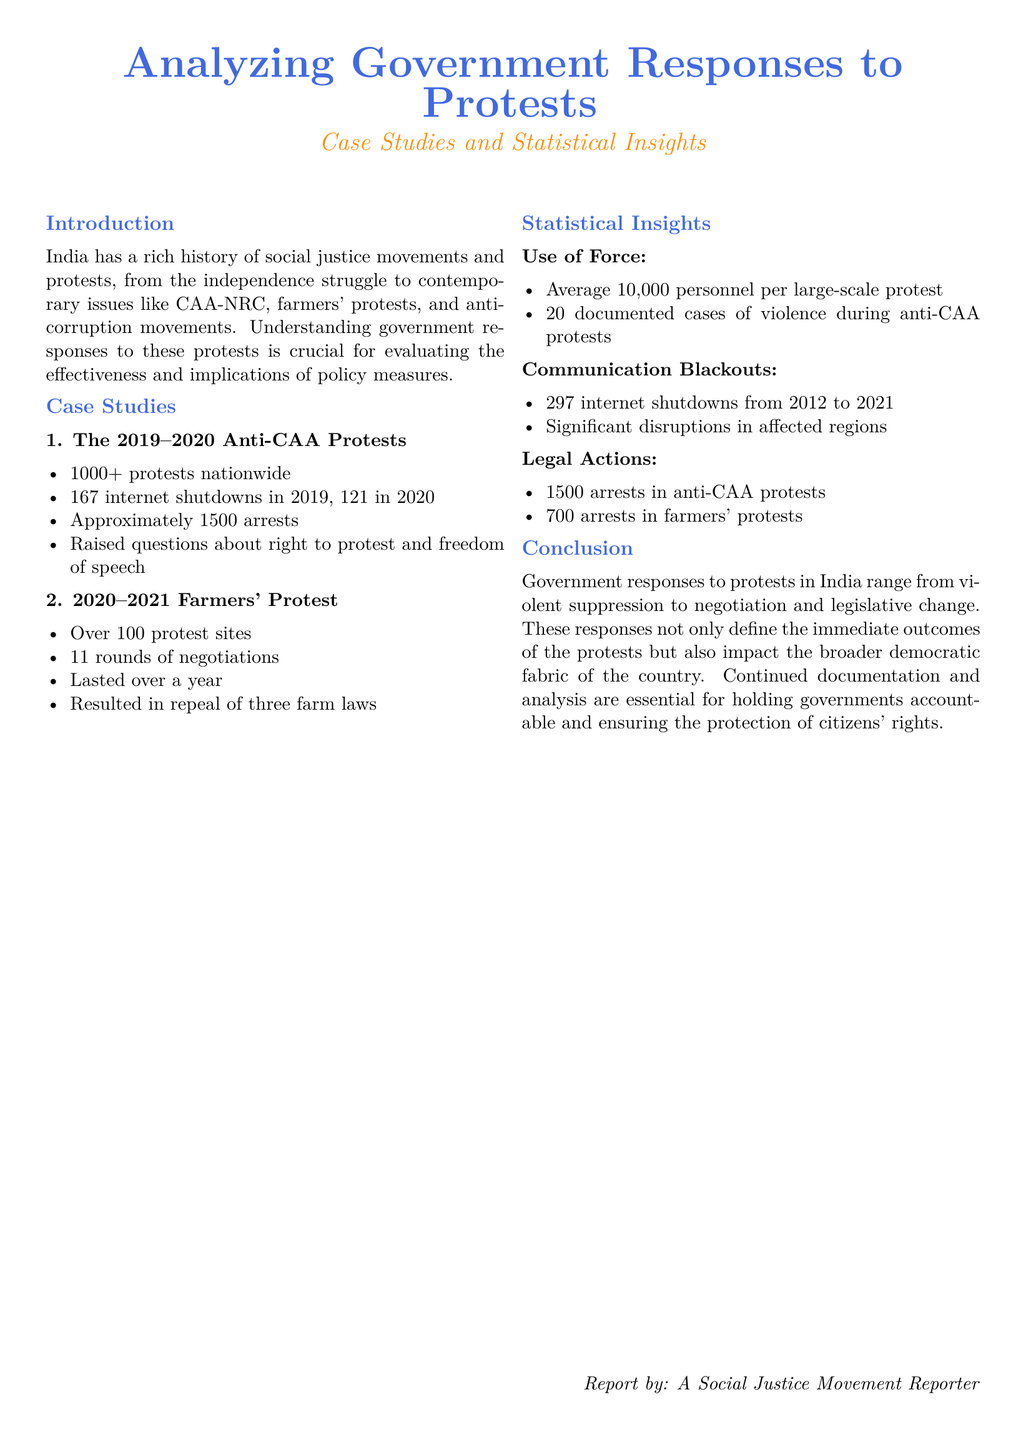what was the total number of protests during the Anti-CAA protests? The document states that there were over 1000 protests nationwide during the Anti-CAA protests.
Answer: over 1000 how many internet shutdowns occurred in 2019? The document lists 167 internet shutdowns in 2019.
Answer: 167 what was the outcome of the farmers' protest? The document mentions that the farmers' protest resulted in the repeal of three farm laws.
Answer: repeal of three farm laws how many documented cases of violence were there during the Anti-CAA protests? The document states there were 20 documented cases of violence during the Anti-CAA protests.
Answer: 20 what was the average number of personnel deployed per large-scale protest? The document notes that on average, 10,000 personnel were deployed per large-scale protest.
Answer: 10,000 how many rounds of negotiations took place during the farmers' protest? The document indicates that there were 11 rounds of negotiations during the farmers' protest.
Answer: 11 how many arrests were made during the farmers' protests? The document specifies that there were 700 arrests in the farmers' protests.
Answer: 700 what is the total number of internet shutdowns from 2012 to 2021? The document mentions 297 internet shutdowns from 2012 to 2021.
Answer: 297 what does the conclusion of the document emphasize? The conclusion emphasizes the need for continued documentation and analysis for holding governments accountable.
Answer: accountability 